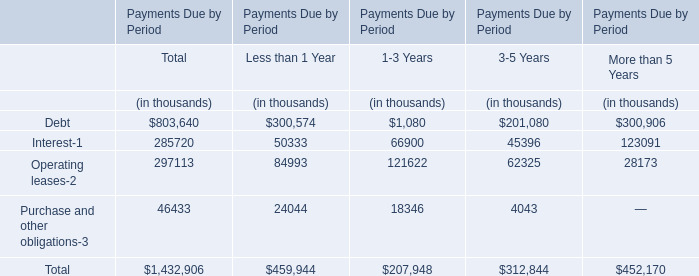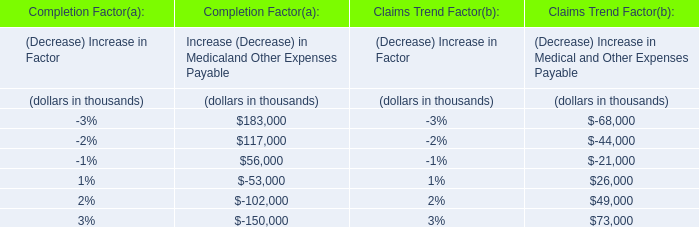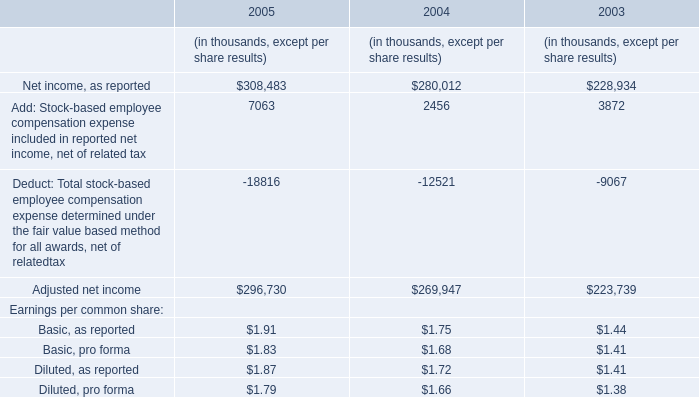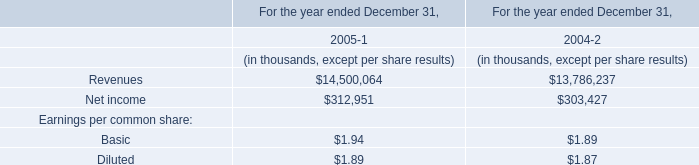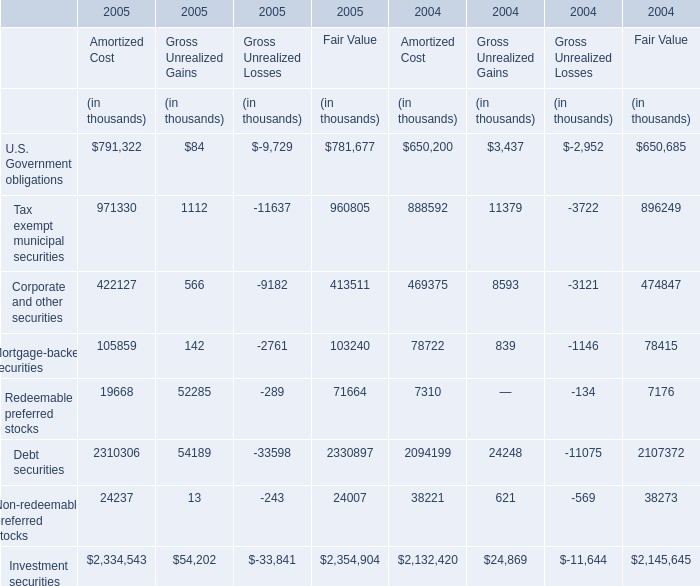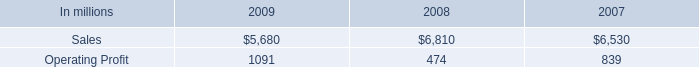north american printing papers net sales where what percent of total printing paper sales in 2008? 
Computations: ((3.4 * 1000) / 6810)
Answer: 0.49927. 